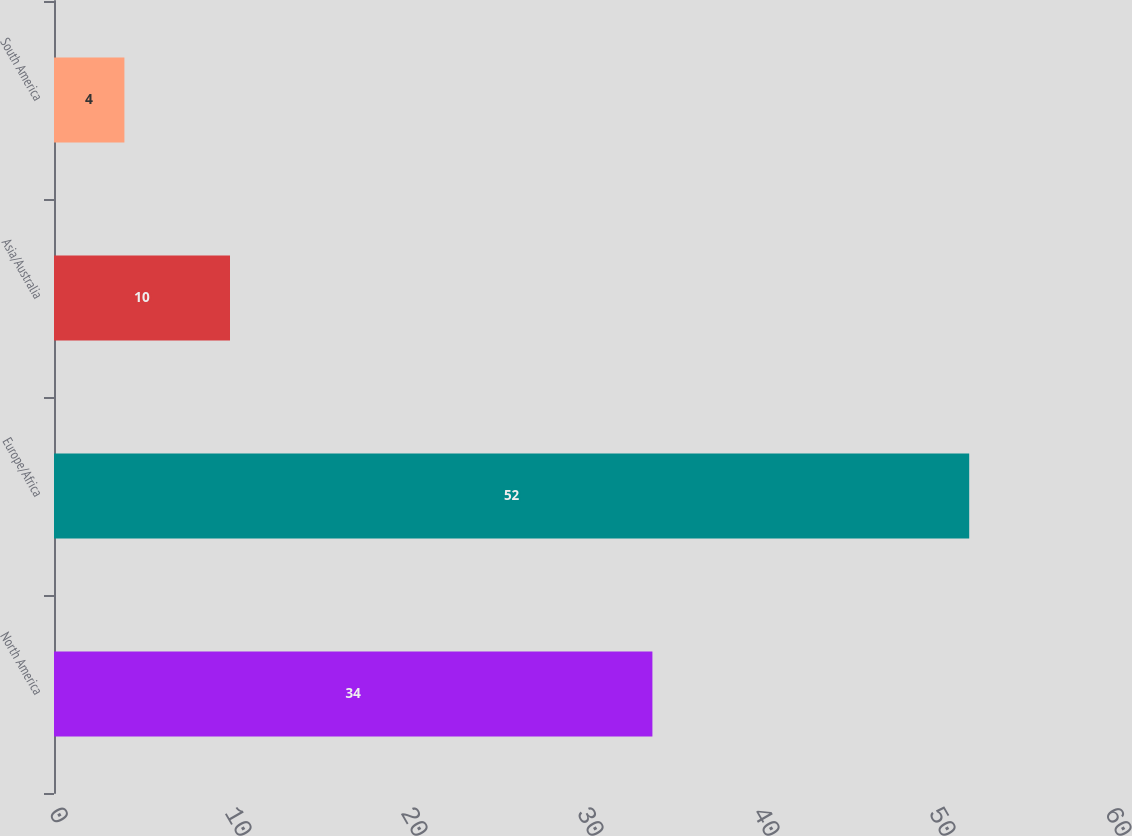Convert chart to OTSL. <chart><loc_0><loc_0><loc_500><loc_500><bar_chart><fcel>North America<fcel>Europe/Africa<fcel>Asia/Australia<fcel>South America<nl><fcel>34<fcel>52<fcel>10<fcel>4<nl></chart> 